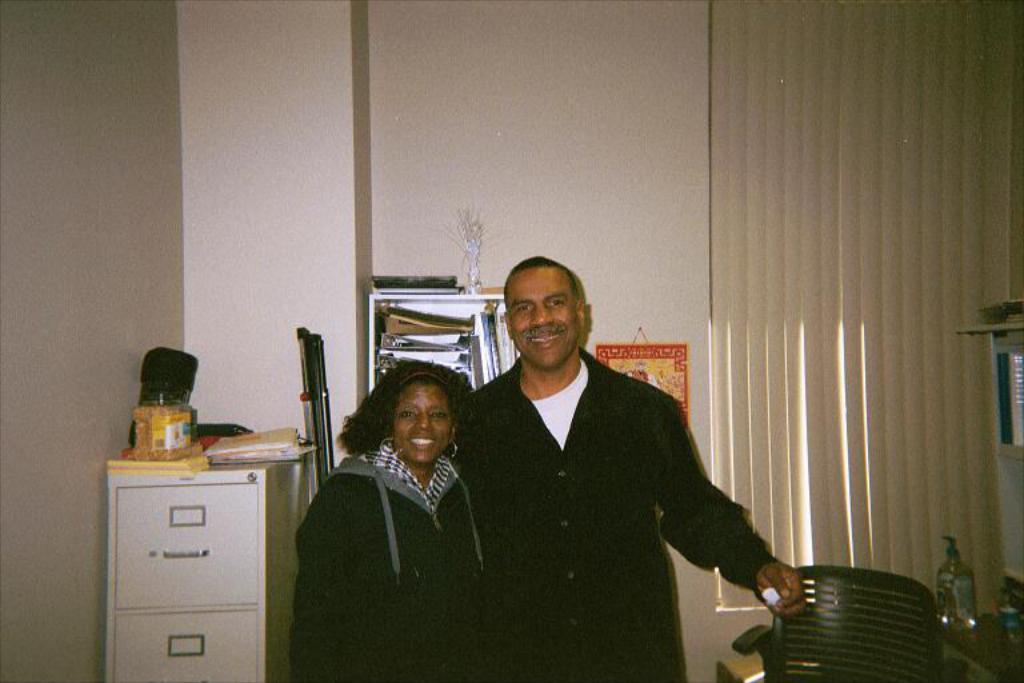Can you describe this image briefly? In this image we can see a man and a woman standing and smiling. Image also consists of a jar, books on the white color object on the left. We can also see the chair, bottle and some objects in the white rack. In the background we can see the wall, window mat and a frame hanged to the plain wall. 